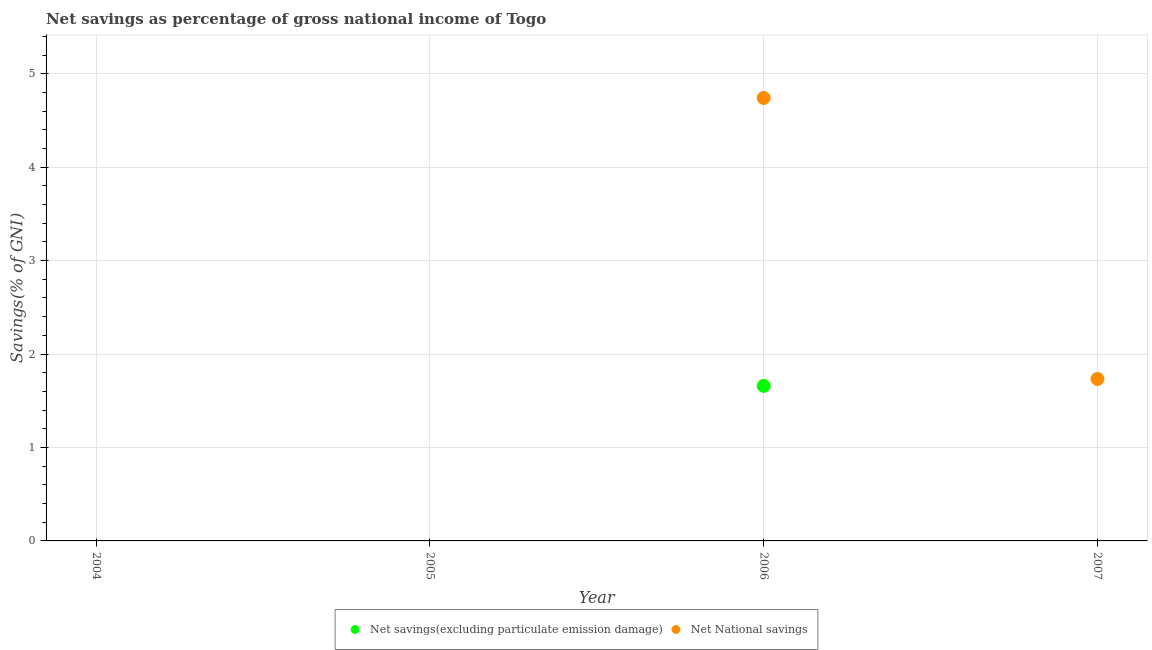Is the number of dotlines equal to the number of legend labels?
Give a very brief answer. No. What is the net national savings in 2004?
Give a very brief answer. 0. Across all years, what is the maximum net national savings?
Your answer should be compact. 4.74. What is the total net savings(excluding particulate emission damage) in the graph?
Provide a short and direct response. 1.66. What is the difference between the net savings(excluding particulate emission damage) in 2007 and the net national savings in 2006?
Offer a terse response. -4.74. What is the average net savings(excluding particulate emission damage) per year?
Give a very brief answer. 0.41. What is the ratio of the net national savings in 2006 to that in 2007?
Give a very brief answer. 2.73. What is the difference between the highest and the lowest net savings(excluding particulate emission damage)?
Provide a succinct answer. 1.66. Does the net national savings monotonically increase over the years?
Your answer should be very brief. No. Is the net savings(excluding particulate emission damage) strictly greater than the net national savings over the years?
Ensure brevity in your answer.  No. How many dotlines are there?
Offer a terse response. 2. What is the difference between two consecutive major ticks on the Y-axis?
Your answer should be compact. 1. Are the values on the major ticks of Y-axis written in scientific E-notation?
Offer a very short reply. No. Does the graph contain any zero values?
Provide a succinct answer. Yes. Where does the legend appear in the graph?
Keep it short and to the point. Bottom center. How are the legend labels stacked?
Make the answer very short. Horizontal. What is the title of the graph?
Your answer should be very brief. Net savings as percentage of gross national income of Togo. Does "From Government" appear as one of the legend labels in the graph?
Your response must be concise. No. What is the label or title of the Y-axis?
Offer a terse response. Savings(% of GNI). What is the Savings(% of GNI) in Net National savings in 2004?
Make the answer very short. 0. What is the Savings(% of GNI) of Net National savings in 2005?
Offer a very short reply. 0. What is the Savings(% of GNI) of Net savings(excluding particulate emission damage) in 2006?
Provide a short and direct response. 1.66. What is the Savings(% of GNI) in Net National savings in 2006?
Your answer should be compact. 4.74. What is the Savings(% of GNI) of Net National savings in 2007?
Your answer should be compact. 1.73. Across all years, what is the maximum Savings(% of GNI) of Net savings(excluding particulate emission damage)?
Your response must be concise. 1.66. Across all years, what is the maximum Savings(% of GNI) in Net National savings?
Offer a very short reply. 4.74. Across all years, what is the minimum Savings(% of GNI) of Net savings(excluding particulate emission damage)?
Ensure brevity in your answer.  0. Across all years, what is the minimum Savings(% of GNI) of Net National savings?
Your response must be concise. 0. What is the total Savings(% of GNI) in Net savings(excluding particulate emission damage) in the graph?
Provide a succinct answer. 1.66. What is the total Savings(% of GNI) in Net National savings in the graph?
Offer a very short reply. 6.47. What is the difference between the Savings(% of GNI) of Net National savings in 2006 and that in 2007?
Provide a succinct answer. 3.01. What is the difference between the Savings(% of GNI) of Net savings(excluding particulate emission damage) in 2006 and the Savings(% of GNI) of Net National savings in 2007?
Your answer should be very brief. -0.07. What is the average Savings(% of GNI) of Net savings(excluding particulate emission damage) per year?
Your answer should be compact. 0.41. What is the average Savings(% of GNI) in Net National savings per year?
Offer a very short reply. 1.62. In the year 2006, what is the difference between the Savings(% of GNI) in Net savings(excluding particulate emission damage) and Savings(% of GNI) in Net National savings?
Give a very brief answer. -3.08. What is the ratio of the Savings(% of GNI) of Net National savings in 2006 to that in 2007?
Offer a very short reply. 2.73. What is the difference between the highest and the lowest Savings(% of GNI) of Net savings(excluding particulate emission damage)?
Your response must be concise. 1.66. What is the difference between the highest and the lowest Savings(% of GNI) in Net National savings?
Your response must be concise. 4.74. 